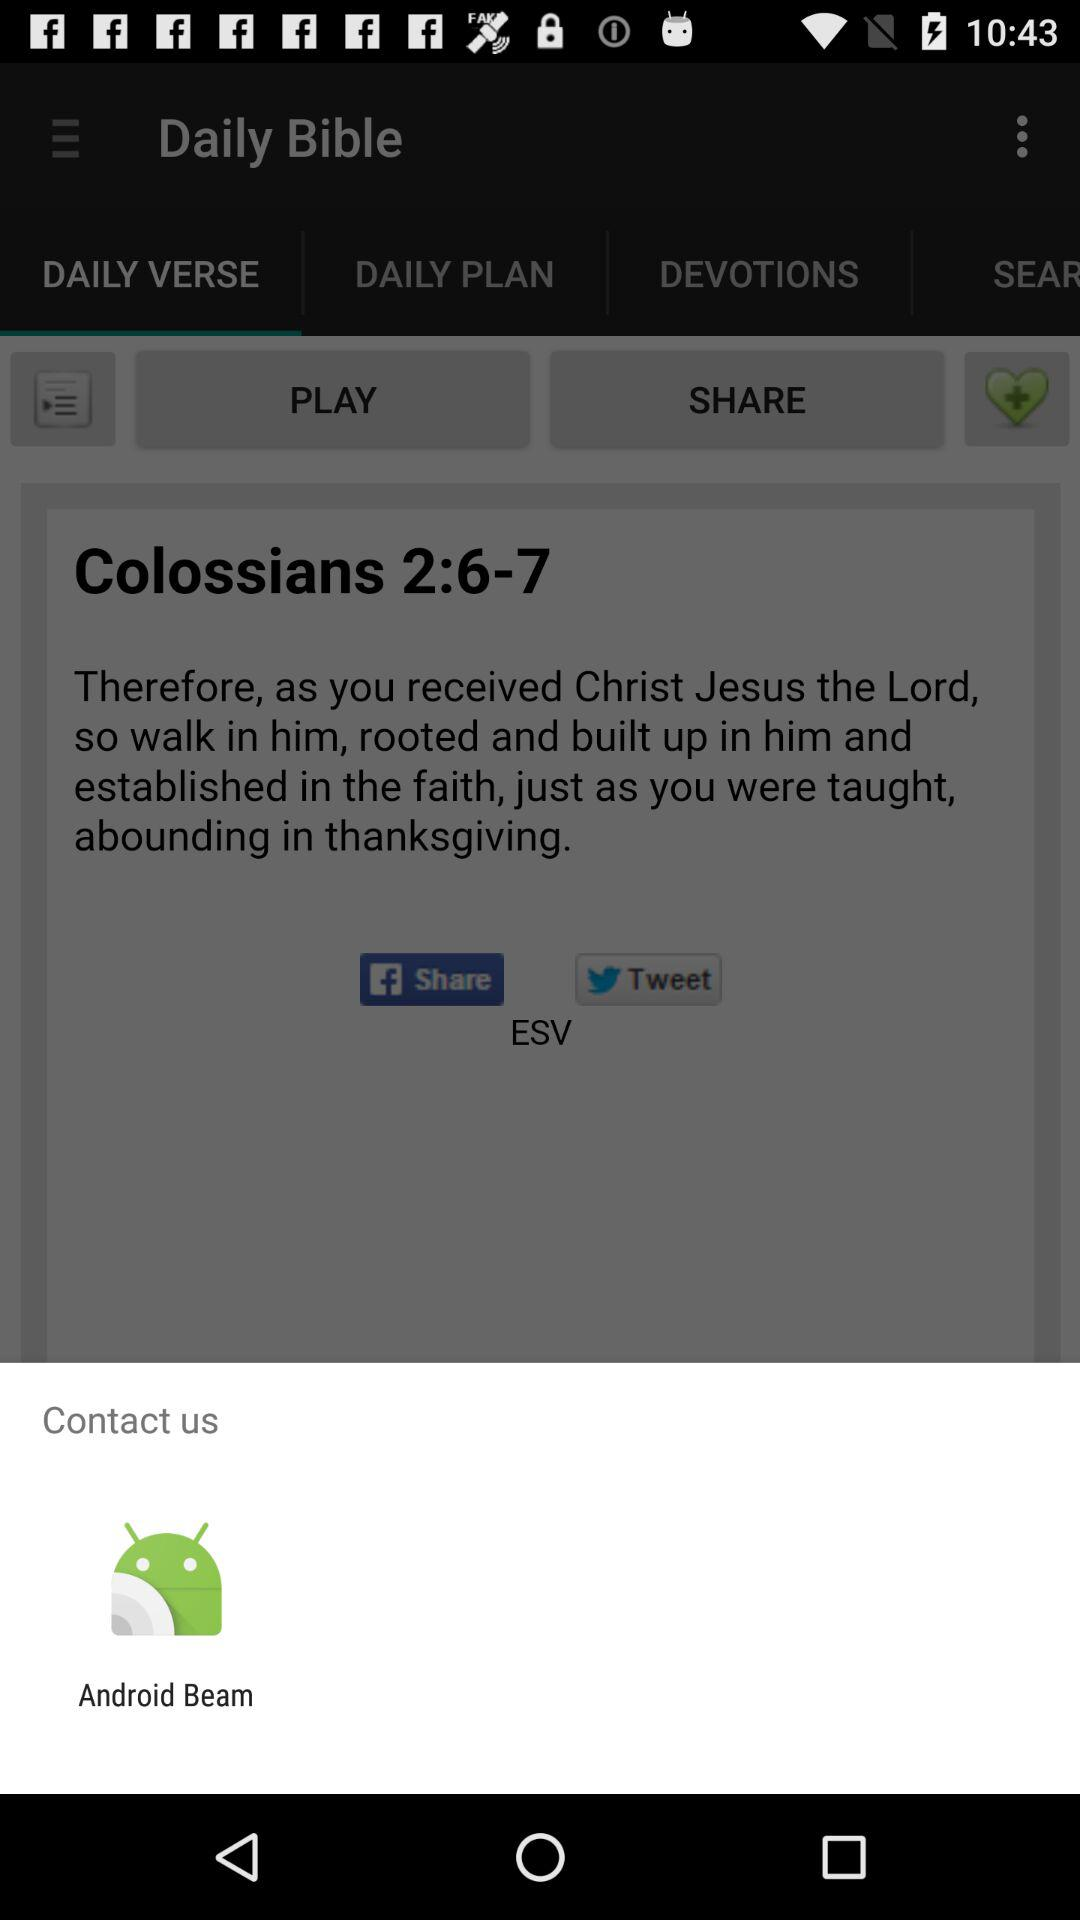What is the option to contact us? The option is "Android Beam". 